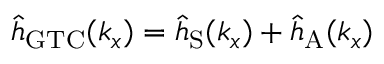Convert formula to latex. <formula><loc_0><loc_0><loc_500><loc_500>{ \hat { h } } _ { G T C } ( k _ { x } ) = { \hat { h } } _ { S } ( { k _ { x } } ) + { \hat { h } } _ { A } ( { k _ { x } } )</formula> 